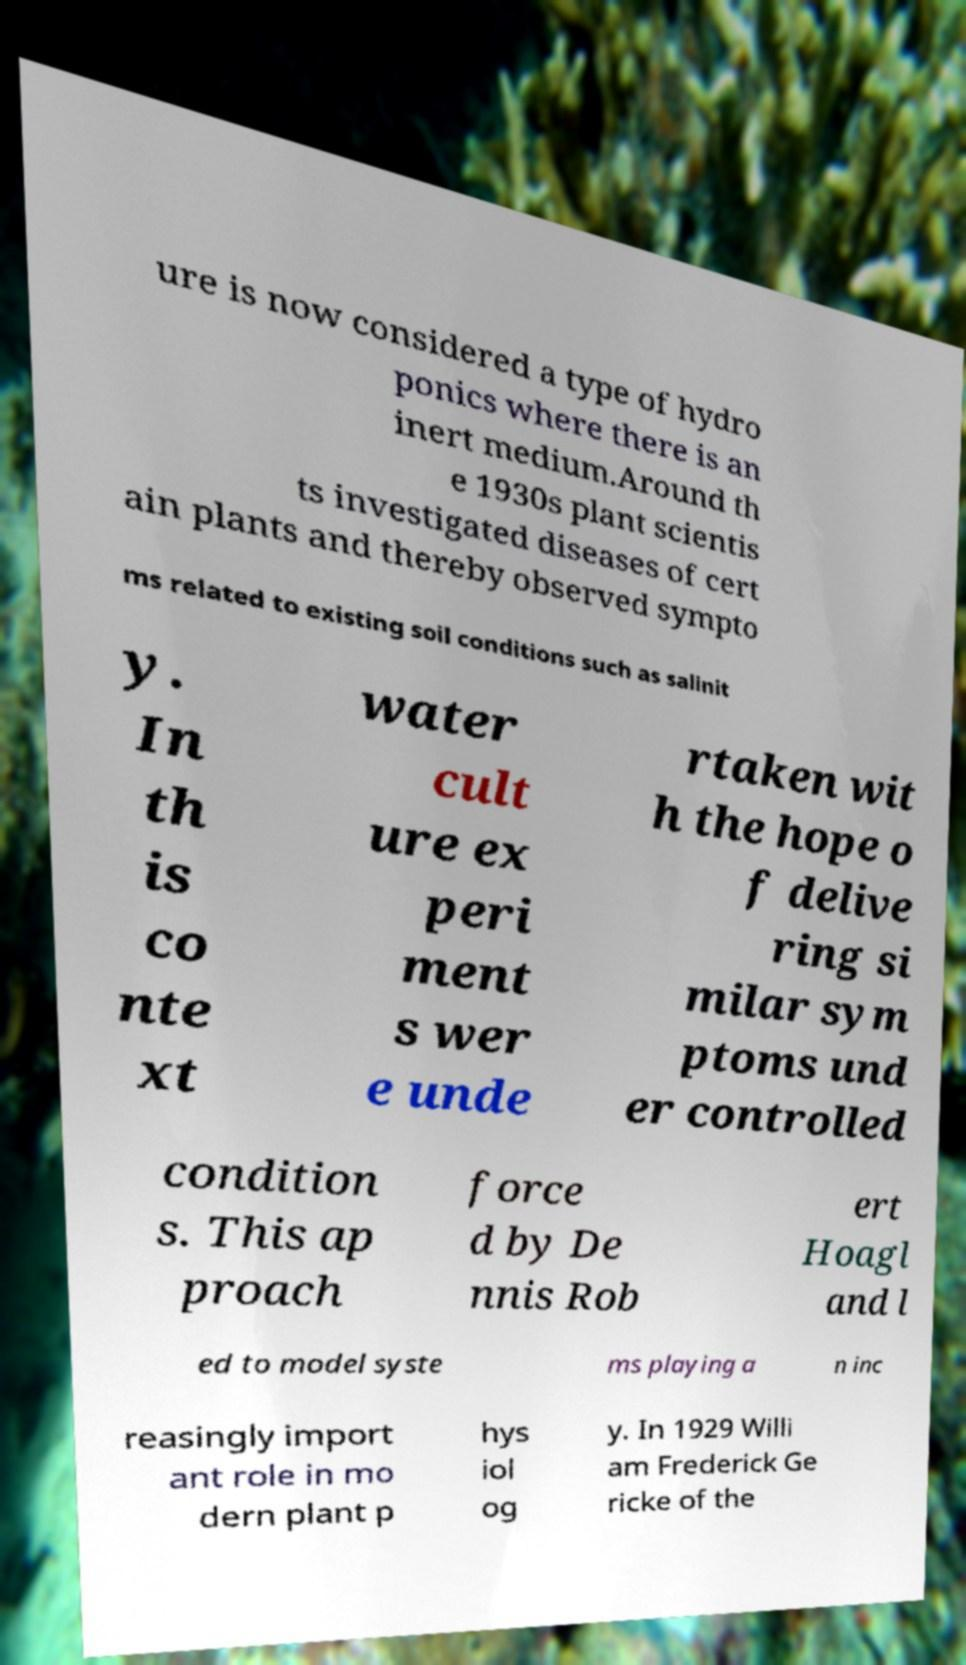There's text embedded in this image that I need extracted. Can you transcribe it verbatim? ure is now considered a type of hydro ponics where there is an inert medium.Around th e 1930s plant scientis ts investigated diseases of cert ain plants and thereby observed sympto ms related to existing soil conditions such as salinit y. In th is co nte xt water cult ure ex peri ment s wer e unde rtaken wit h the hope o f delive ring si milar sym ptoms und er controlled condition s. This ap proach force d by De nnis Rob ert Hoagl and l ed to model syste ms playing a n inc reasingly import ant role in mo dern plant p hys iol og y. In 1929 Willi am Frederick Ge ricke of the 